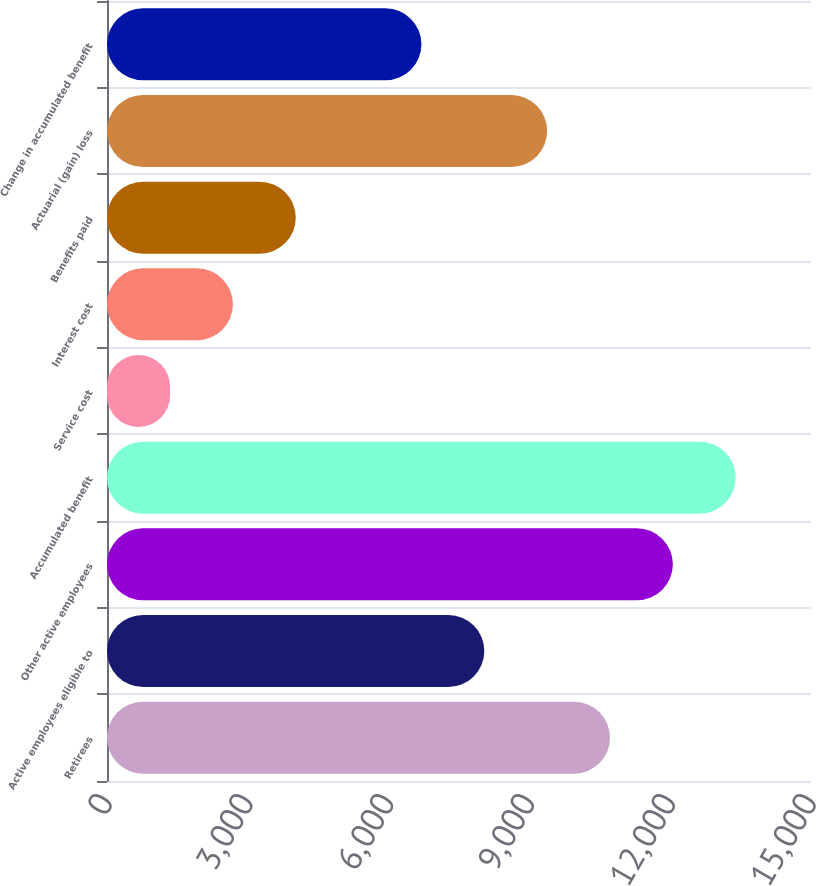Convert chart. <chart><loc_0><loc_0><loc_500><loc_500><bar_chart><fcel>Retirees<fcel>Active employees eligible to<fcel>Other active employees<fcel>Accumulated benefit<fcel>Service cost<fcel>Interest cost<fcel>Benefits paid<fcel>Actuarial (gain) loss<fcel>Change in accumulated benefit<nl><fcel>10717.7<fcel>8039.49<fcel>12056.9<fcel>13396<fcel>1343.89<fcel>2683.01<fcel>4022.13<fcel>9378.61<fcel>6700.37<nl></chart> 